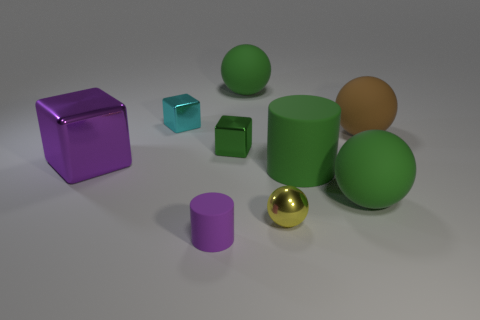Subtract 1 spheres. How many spheres are left? 3 Add 1 small red blocks. How many objects exist? 10 Subtract all cylinders. How many objects are left? 7 Add 3 matte balls. How many matte balls exist? 6 Subtract 0 gray cubes. How many objects are left? 9 Subtract all brown metallic cylinders. Subtract all small yellow metal things. How many objects are left? 8 Add 3 yellow balls. How many yellow balls are left? 4 